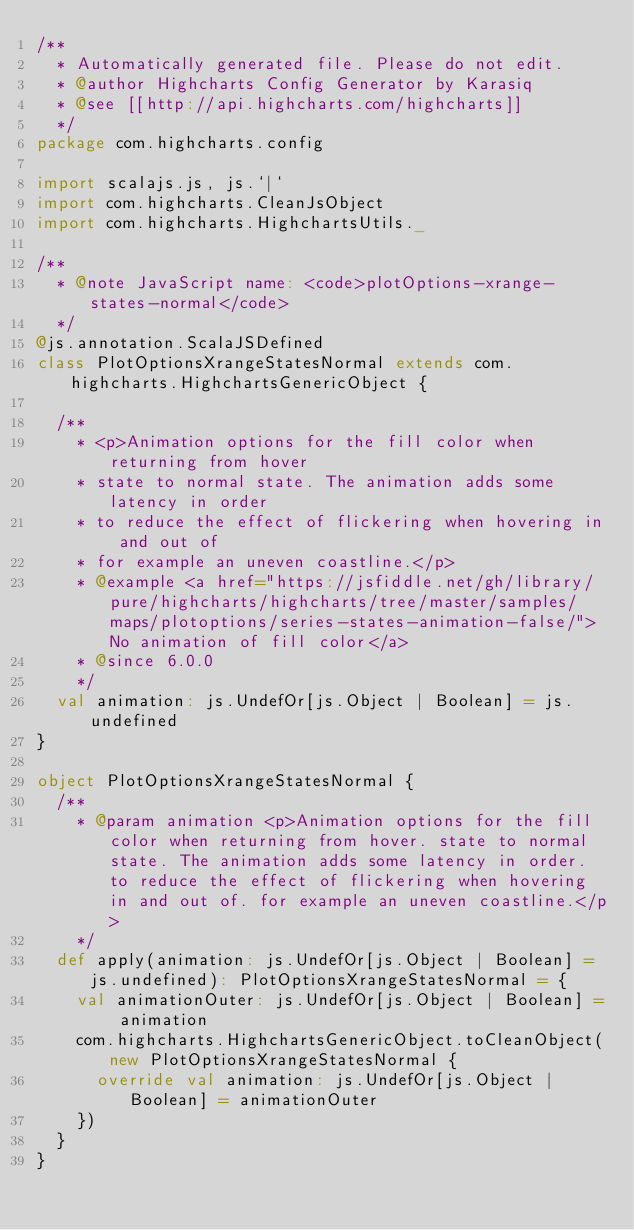<code> <loc_0><loc_0><loc_500><loc_500><_Scala_>/**
  * Automatically generated file. Please do not edit.
  * @author Highcharts Config Generator by Karasiq
  * @see [[http://api.highcharts.com/highcharts]]
  */
package com.highcharts.config

import scalajs.js, js.`|`
import com.highcharts.CleanJsObject
import com.highcharts.HighchartsUtils._

/**
  * @note JavaScript name: <code>plotOptions-xrange-states-normal</code>
  */
@js.annotation.ScalaJSDefined
class PlotOptionsXrangeStatesNormal extends com.highcharts.HighchartsGenericObject {

  /**
    * <p>Animation options for the fill color when returning from hover
    * state to normal state. The animation adds some latency in order
    * to reduce the effect of flickering when hovering in and out of
    * for example an uneven coastline.</p>
    * @example <a href="https://jsfiddle.net/gh/library/pure/highcharts/highcharts/tree/master/samples/maps/plotoptions/series-states-animation-false/">No animation of fill color</a>
    * @since 6.0.0
    */
  val animation: js.UndefOr[js.Object | Boolean] = js.undefined
}

object PlotOptionsXrangeStatesNormal {
  /**
    * @param animation <p>Animation options for the fill color when returning from hover. state to normal state. The animation adds some latency in order. to reduce the effect of flickering when hovering in and out of. for example an uneven coastline.</p>
    */
  def apply(animation: js.UndefOr[js.Object | Boolean] = js.undefined): PlotOptionsXrangeStatesNormal = {
    val animationOuter: js.UndefOr[js.Object | Boolean] = animation
    com.highcharts.HighchartsGenericObject.toCleanObject(new PlotOptionsXrangeStatesNormal {
      override val animation: js.UndefOr[js.Object | Boolean] = animationOuter
    })
  }
}
</code> 